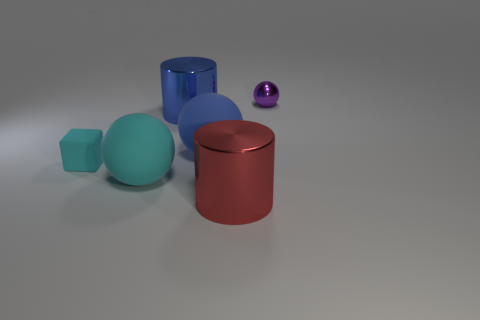Add 2 big brown matte blocks. How many objects exist? 8 Subtract all cubes. How many objects are left? 5 Subtract 0 gray balls. How many objects are left? 6 Subtract all metal balls. Subtract all small purple metallic things. How many objects are left? 4 Add 5 blue cylinders. How many blue cylinders are left? 6 Add 2 tiny metallic things. How many tiny metallic things exist? 3 